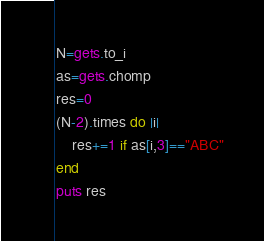Convert code to text. <code><loc_0><loc_0><loc_500><loc_500><_Ruby_>N=gets.to_i
as=gets.chomp
res=0
(N-2).times do |i|
    res+=1 if as[i,3]=="ABC"
end
puts res</code> 